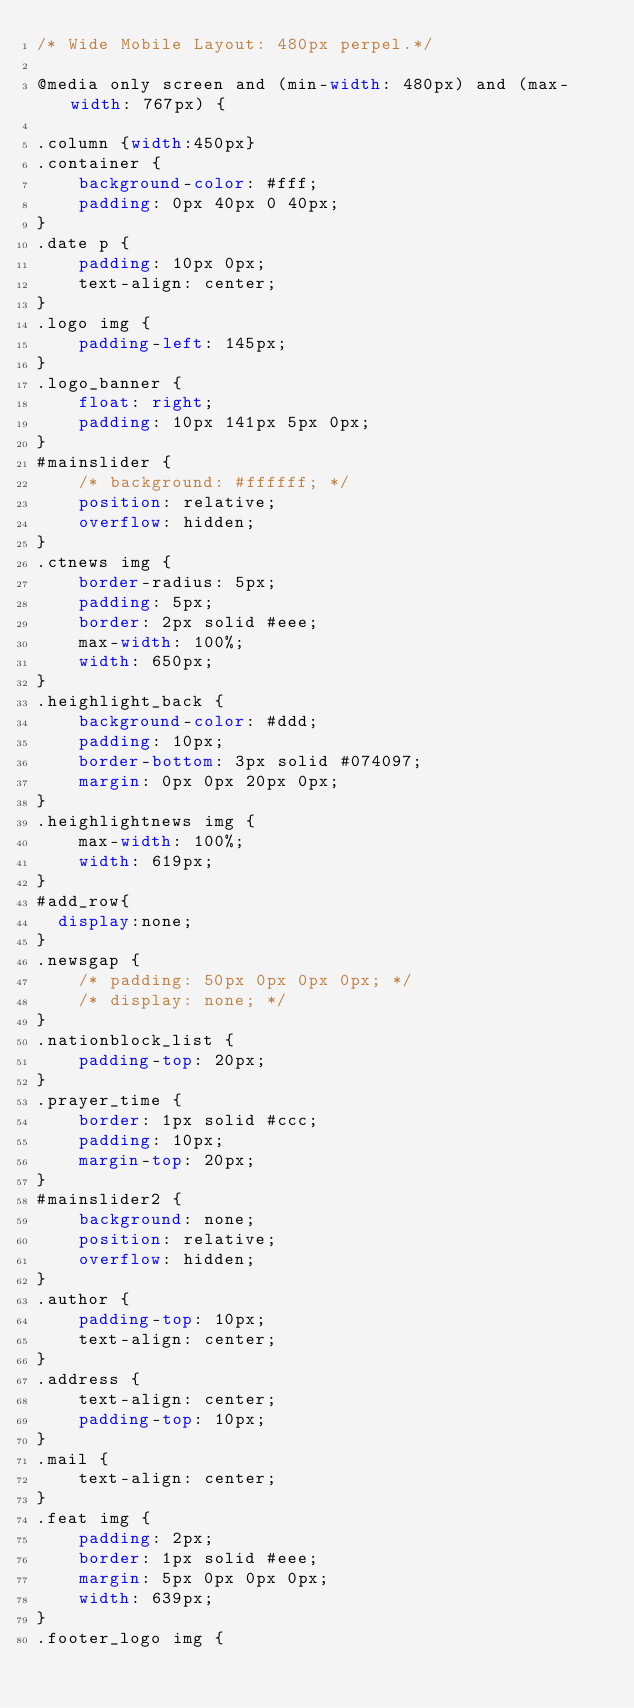<code> <loc_0><loc_0><loc_500><loc_500><_CSS_>/* Wide Mobile Layout: 480px perpel.*/

@media only screen and (min-width: 480px) and (max-width: 767px) {

.column {width:450px}
.container {
    background-color: #fff;
    padding: 0px 40px 0 40px;
}
.date p {
    padding: 10px 0px;
    text-align: center;
}
.logo img {
    padding-left: 145px;
}
.logo_banner {
    float: right;
    padding: 10px 141px 5px 0px;
}
#mainslider {
    /* background: #ffffff; */
    position: relative;
    overflow: hidden;
}
.ctnews img {
    border-radius: 5px;
    padding: 5px;
    border: 2px solid #eee;
    max-width: 100%;
    width: 650px;
}
.heighlight_back {
    background-color: #ddd;
    padding: 10px;
    border-bottom: 3px solid #074097;
    margin: 0px 0px 20px 0px;
}
.heighlightnews img {
    max-width: 100%;
    width: 619px;
}
#add_row{
	display:none;
}
.newsgap {
    /* padding: 50px 0px 0px 0px; */
    /* display: none; */
}
.nationblock_list {
    padding-top: 20px;
}
.prayer_time {
    border: 1px solid #ccc;
    padding: 10px;
    margin-top: 20px;
}
#mainslider2 {
    background: none;
    position: relative;
    overflow: hidden;
}
.author {
    padding-top: 10px;
    text-align: center;
}
.address {
    text-align: center;
    padding-top: 10px;
}
.mail {
    text-align: center;
}
.feat img {
    padding: 2px;
    border: 1px solid #eee;
    margin: 5px 0px 0px 0px;
    width: 639px;
}
.footer_logo img {</code> 